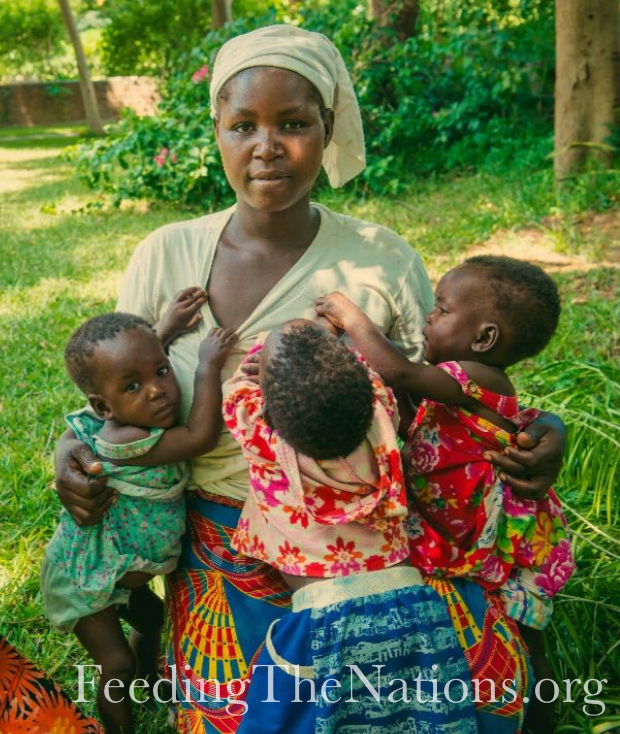What might be the relationship between the woman and the children, and what clues in the image lead to that conclusion? The relationship between the woman and the children appears to be that of a primary caregiver, possibly their mother. This interpretation stems from the nurturing manner in which she holds the children, one comfortably nestled against her back wrapped in a vibrant cloth and another held closely by the hip. Such methods of carrying children are prevalent in various parts of Africa, signifying a deep, maternal bond. The children’s expressions and casual posture towards the woman suggest a familial or a similarly intimate connection. Additionally, the color-coordinated and pattern-rich attire shared between the woman and the children hints at a family unit, often seen in communal and family-oriented cultures. 